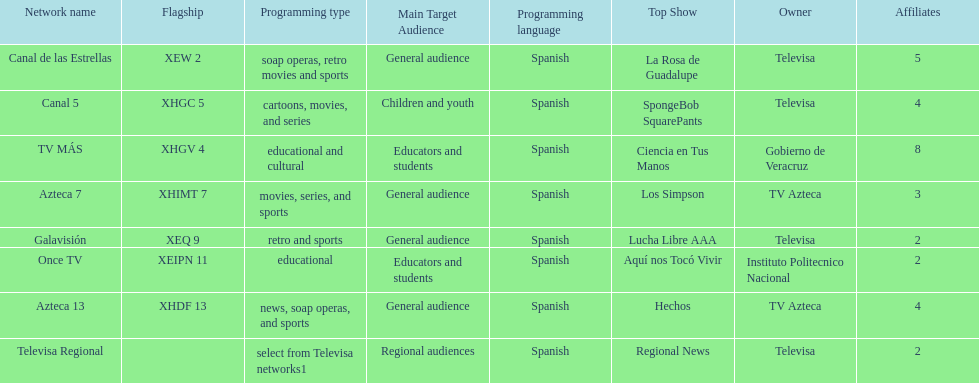Who has the most number of affiliates? TV MÁS. 